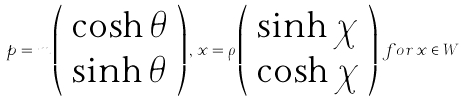Convert formula to latex. <formula><loc_0><loc_0><loc_500><loc_500>p = m \left ( \begin{array} { l } \cosh \theta \\ \sinh \theta \end{array} \right ) , \, x = \rho \left ( \begin{array} { l } \sinh \chi \\ \cosh \chi \end{array} \right ) \, f o r \, x \in W</formula> 